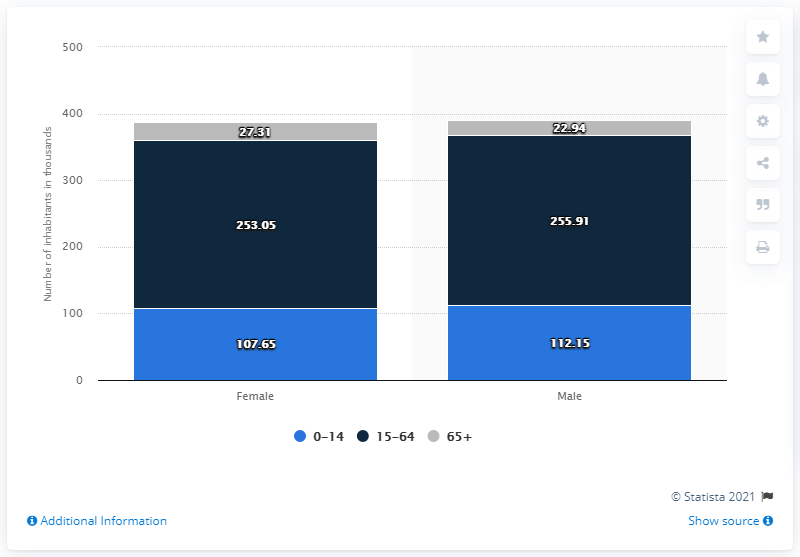Outline some significant characteristics in this image. The oldest age range in Guyana is 65 years old and above. 